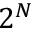Convert formula to latex. <formula><loc_0><loc_0><loc_500><loc_500>2 ^ { N }</formula> 